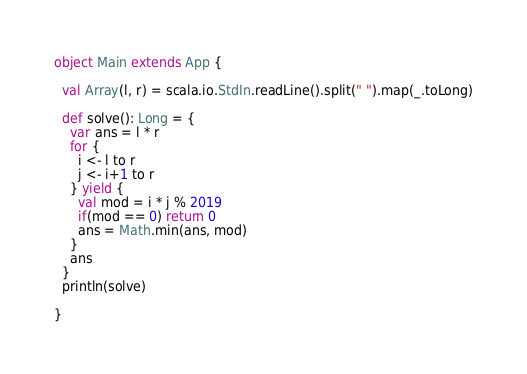<code> <loc_0><loc_0><loc_500><loc_500><_Scala_>object Main extends App {

  val Array(l, r) = scala.io.StdIn.readLine().split(" ").map(_.toLong)

  def solve(): Long = {
    var ans = l * r
    for {
      i <- l to r
      j <- i+1 to r
    } yield {
      val mod = i * j % 2019
      if(mod == 0) return 0
      ans = Math.min(ans, mod)
    }
    ans
  }
  println(solve)

}
</code> 